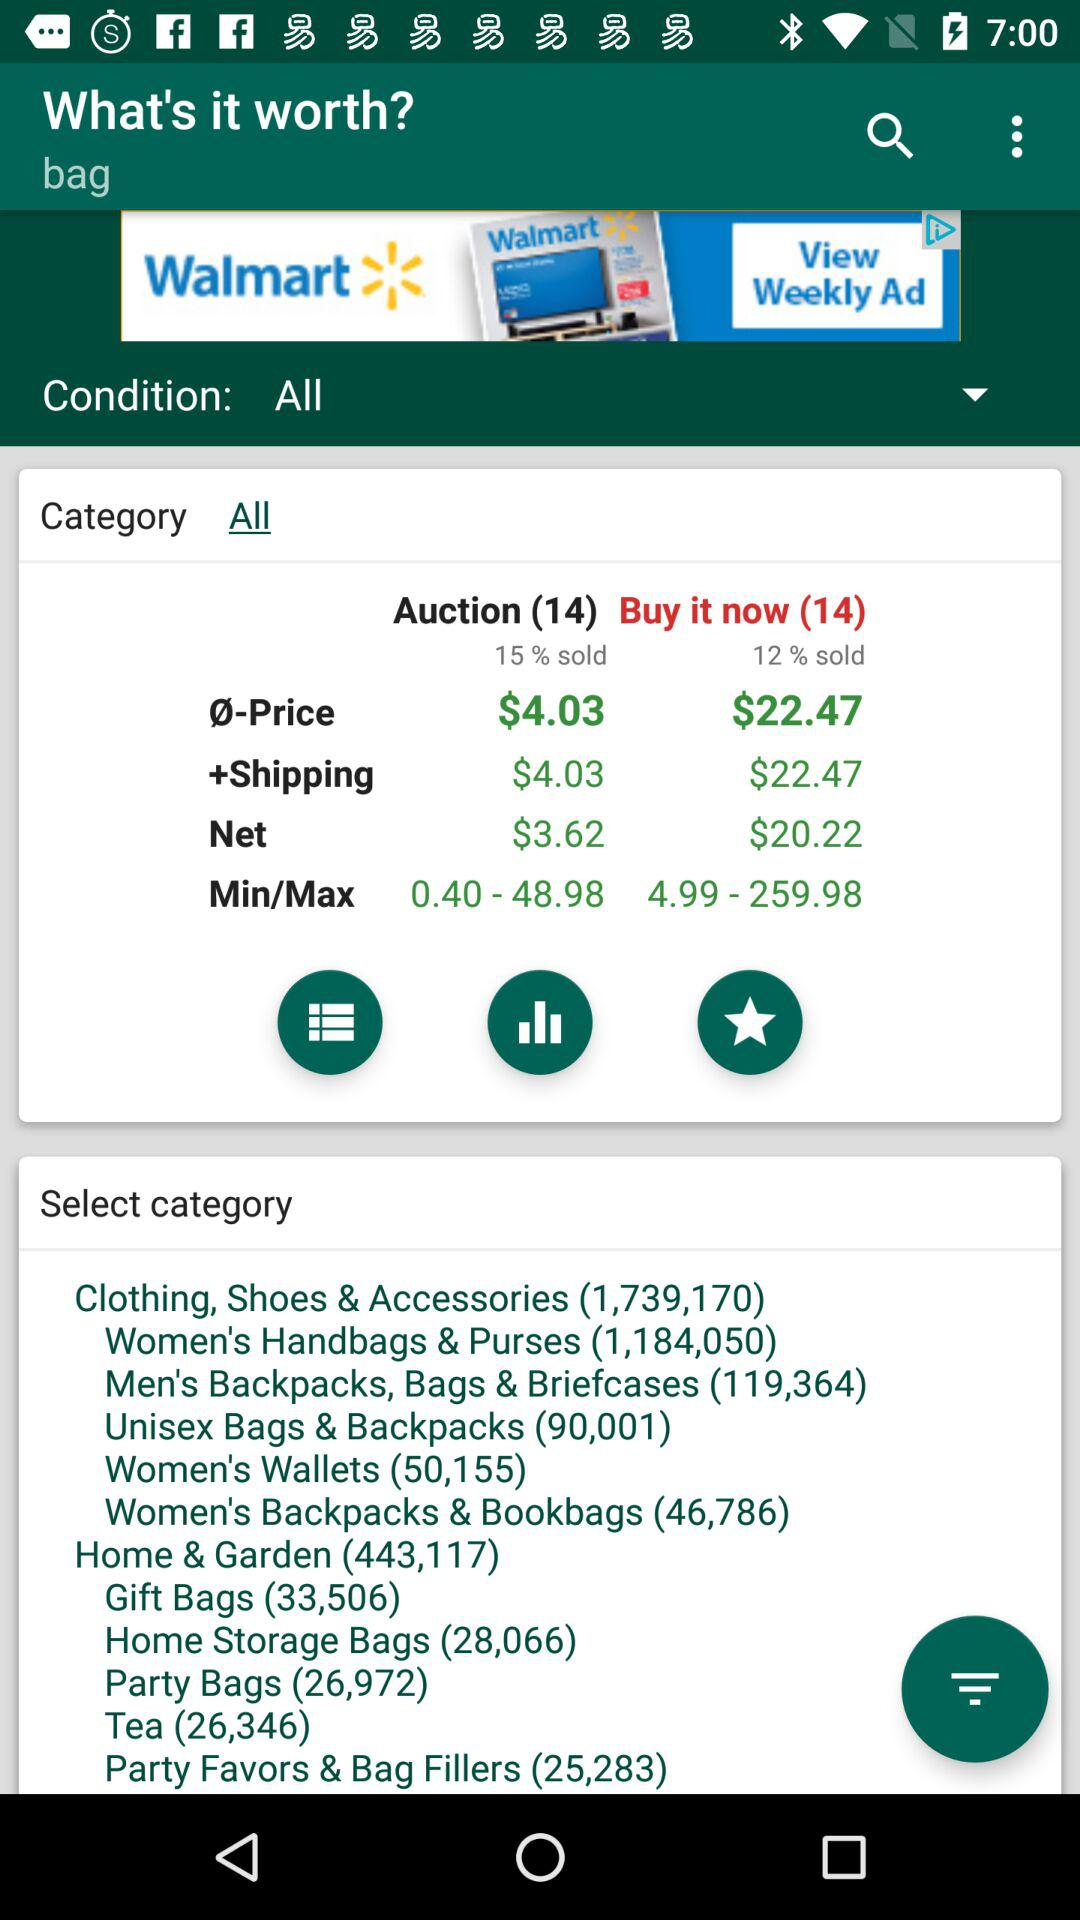What is the Buy It Now price? The Buy It Now price is $22.47. 